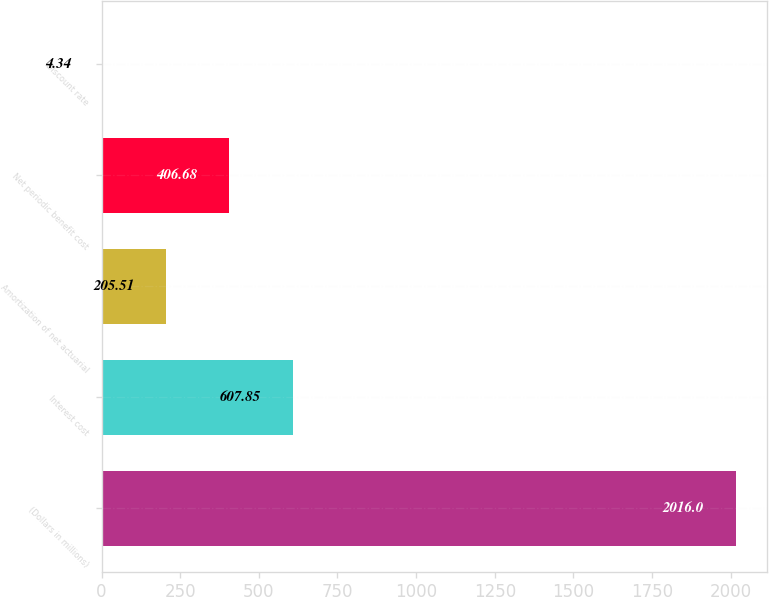<chart> <loc_0><loc_0><loc_500><loc_500><bar_chart><fcel>(Dollars in millions)<fcel>Interest cost<fcel>Amortization of net actuarial<fcel>Net periodic benefit cost<fcel>Discount rate<nl><fcel>2016<fcel>607.85<fcel>205.51<fcel>406.68<fcel>4.34<nl></chart> 